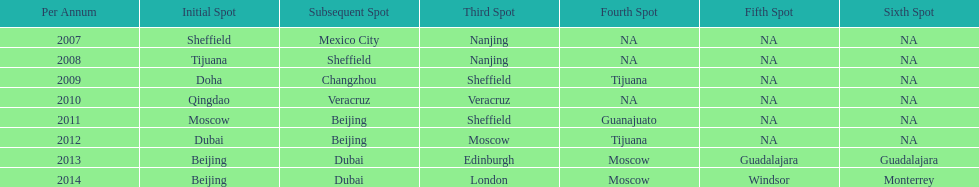Help me parse the entirety of this table. {'header': ['Per Annum', 'Initial Spot', 'Subsequent Spot', 'Third Spot', 'Fourth Spot', 'Fifth Spot', 'Sixth Spot'], 'rows': [['2007', 'Sheffield', 'Mexico City', 'Nanjing', 'NA', 'NA', 'NA'], ['2008', 'Tijuana', 'Sheffield', 'Nanjing', 'NA', 'NA', 'NA'], ['2009', 'Doha', 'Changzhou', 'Sheffield', 'Tijuana', 'NA', 'NA'], ['2010', 'Qingdao', 'Veracruz', 'Veracruz', 'NA', 'NA', 'NA'], ['2011', 'Moscow', 'Beijing', 'Sheffield', 'Guanajuato', 'NA', 'NA'], ['2012', 'Dubai', 'Beijing', 'Moscow', 'Tijuana', 'NA', 'NA'], ['2013', 'Beijing', 'Dubai', 'Edinburgh', 'Moscow', 'Guadalajara', 'Guadalajara'], ['2014', 'Beijing', 'Dubai', 'London', 'Moscow', 'Windsor', 'Monterrey']]} Which two venue has no nations from 2007-2012 5th Venue, 6th Venue. 